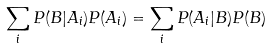Convert formula to latex. <formula><loc_0><loc_0><loc_500><loc_500>\sum _ { i } { P ( B | A _ { i } ) P ( A _ { i } ) } = \sum _ { i } { P ( A _ { i } | B ) P ( B ) }</formula> 